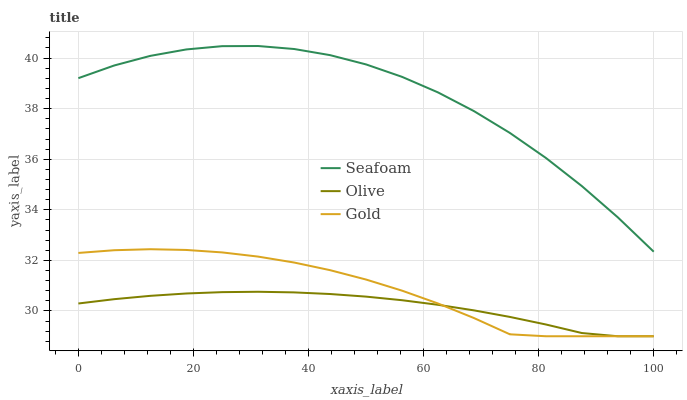Does Gold have the minimum area under the curve?
Answer yes or no. No. Does Gold have the maximum area under the curve?
Answer yes or no. No. Is Gold the smoothest?
Answer yes or no. No. Is Gold the roughest?
Answer yes or no. No. Does Seafoam have the lowest value?
Answer yes or no. No. Does Gold have the highest value?
Answer yes or no. No. Is Gold less than Seafoam?
Answer yes or no. Yes. Is Seafoam greater than Olive?
Answer yes or no. Yes. Does Gold intersect Seafoam?
Answer yes or no. No. 